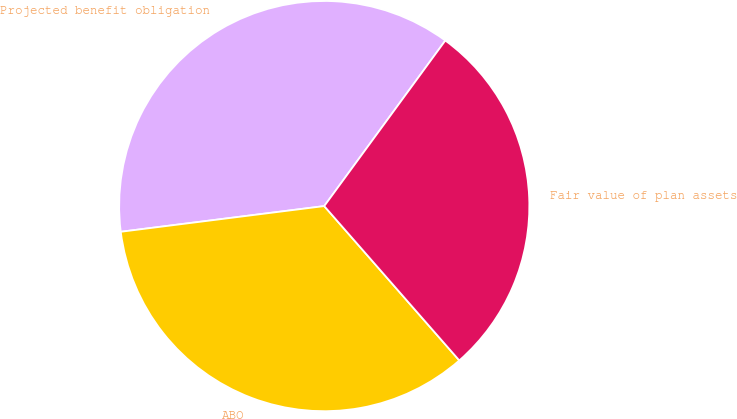<chart> <loc_0><loc_0><loc_500><loc_500><pie_chart><fcel>Projected benefit obligation<fcel>ABO<fcel>Fair value of plan assets<nl><fcel>37.05%<fcel>34.44%<fcel>28.51%<nl></chart> 